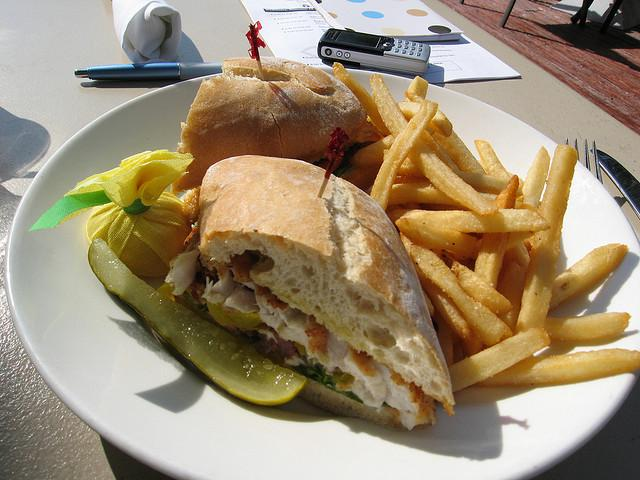Which food element here is likely most sour? Please explain your reasoning. pickle. Pickles are made with vinegar. 